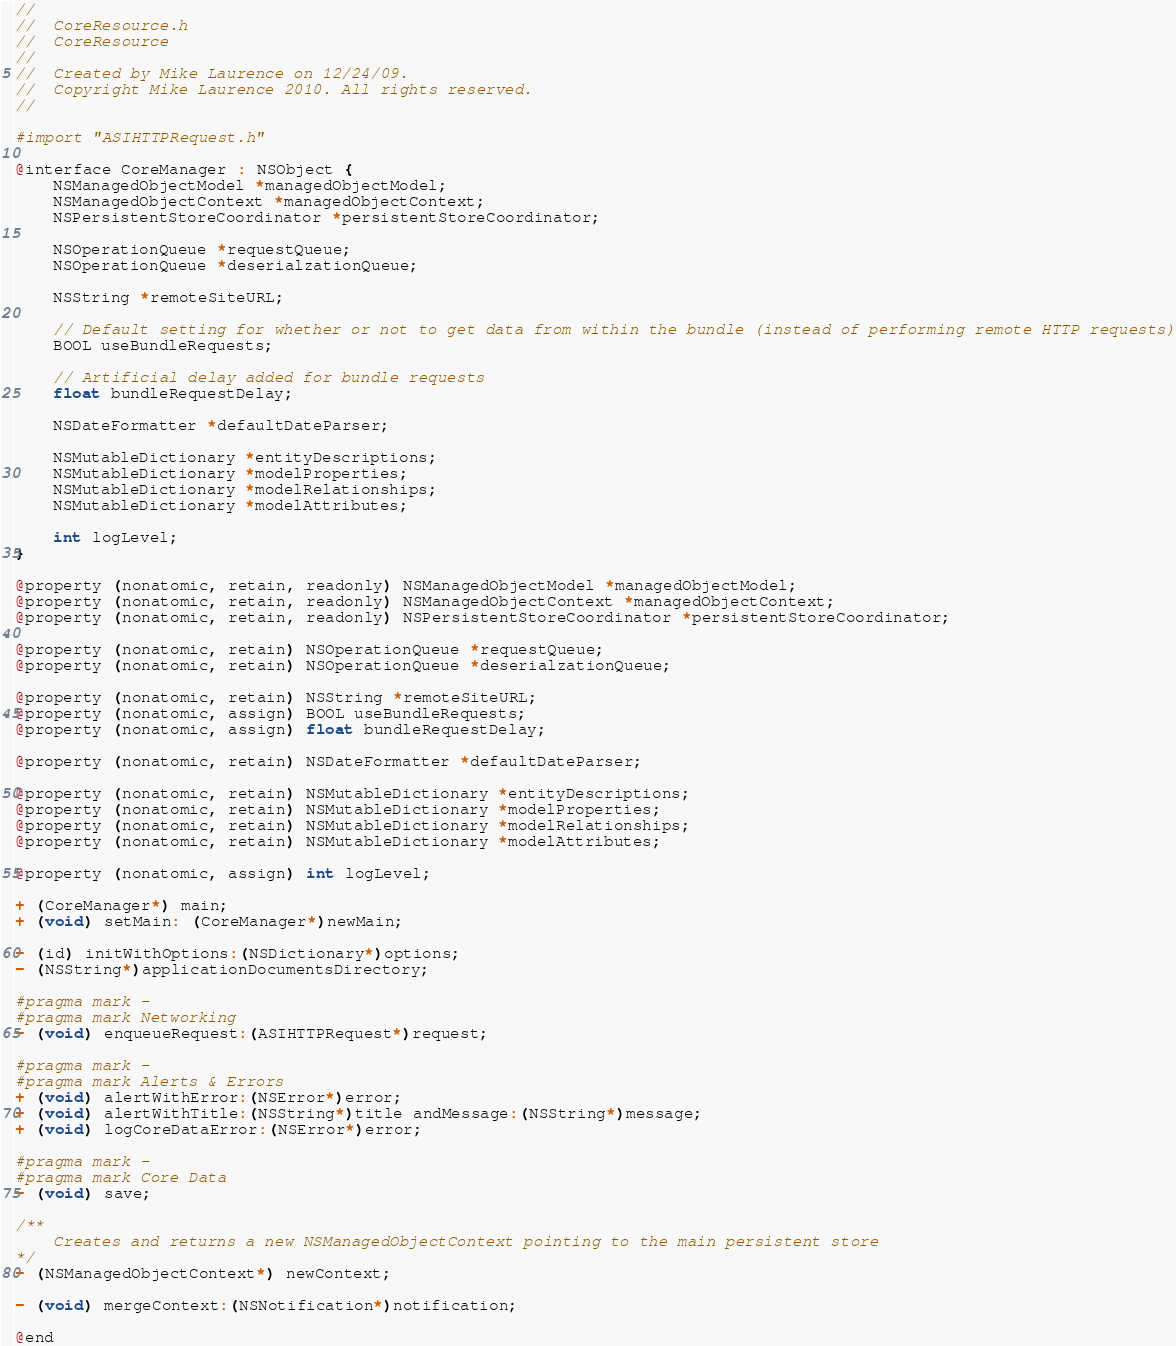<code> <loc_0><loc_0><loc_500><loc_500><_C_>//
//  CoreResource.h
//  CoreResource
//
//  Created by Mike Laurence on 12/24/09.
//  Copyright Mike Laurence 2010. All rights reserved.
//

#import "ASIHTTPRequest.h"

@interface CoreManager : NSObject {
    NSManagedObjectModel *managedObjectModel;
    NSManagedObjectContext *managedObjectContext;
    NSPersistentStoreCoordinator *persistentStoreCoordinator;
    
    NSOperationQueue *requestQueue;
    NSOperationQueue *deserialzationQueue;
    
    NSString *remoteSiteURL;
    
    // Default setting for whether or not to get data from within the bundle (instead of performing remote HTTP requests)
    BOOL useBundleRequests;

    // Artificial delay added for bundle requests
    float bundleRequestDelay;

    NSDateFormatter *defaultDateParser;
    
    NSMutableDictionary *entityDescriptions;
    NSMutableDictionary *modelProperties;
    NSMutableDictionary *modelRelationships;
    NSMutableDictionary *modelAttributes;
    
    int logLevel;
}

@property (nonatomic, retain, readonly) NSManagedObjectModel *managedObjectModel;
@property (nonatomic, retain, readonly) NSManagedObjectContext *managedObjectContext;
@property (nonatomic, retain, readonly) NSPersistentStoreCoordinator *persistentStoreCoordinator;

@property (nonatomic, retain) NSOperationQueue *requestQueue;
@property (nonatomic, retain) NSOperationQueue *deserialzationQueue;

@property (nonatomic, retain) NSString *remoteSiteURL;
@property (nonatomic, assign) BOOL useBundleRequests;
@property (nonatomic, assign) float bundleRequestDelay;

@property (nonatomic, retain) NSDateFormatter *defaultDateParser;

@property (nonatomic, retain) NSMutableDictionary *entityDescriptions;
@property (nonatomic, retain) NSMutableDictionary *modelProperties;
@property (nonatomic, retain) NSMutableDictionary *modelRelationships;
@property (nonatomic, retain) NSMutableDictionary *modelAttributes;

@property (nonatomic, assign) int logLevel;

+ (CoreManager*) main;
+ (void) setMain: (CoreManager*)newMain;

- (id) initWithOptions:(NSDictionary*)options;
- (NSString*)applicationDocumentsDirectory;

#pragma mark -
#pragma mark Networking
- (void) enqueueRequest:(ASIHTTPRequest*)request;

#pragma mark -
#pragma mark Alerts & Errors
+ (void) alertWithError:(NSError*)error;
+ (void) alertWithTitle:(NSString*)title andMessage:(NSString*)message;
+ (void) logCoreDataError:(NSError*)error;

#pragma mark -
#pragma mark Core Data
- (void) save;

/**
    Creates and returns a new NSManagedObjectContext pointing to the main persistent store
*/
- (NSManagedObjectContext*) newContext;

- (void) mergeContext:(NSNotification*)notification;

@end

</code> 